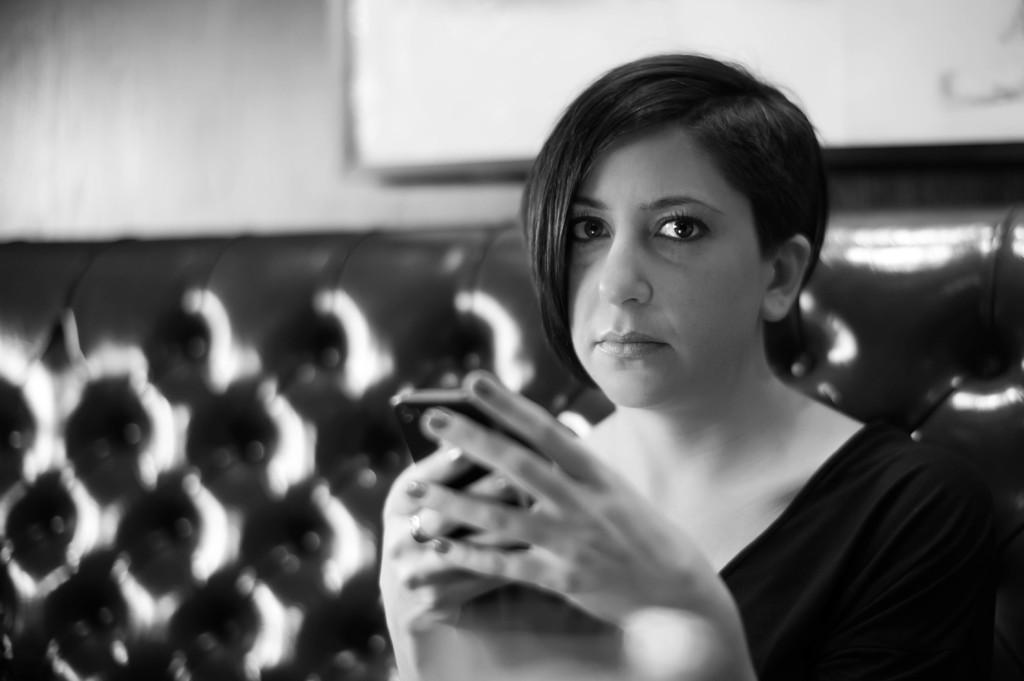Please provide a concise description of this image. This is a black and white picture of a woman holding a cellphone sitting on sofa in front of the wall. 